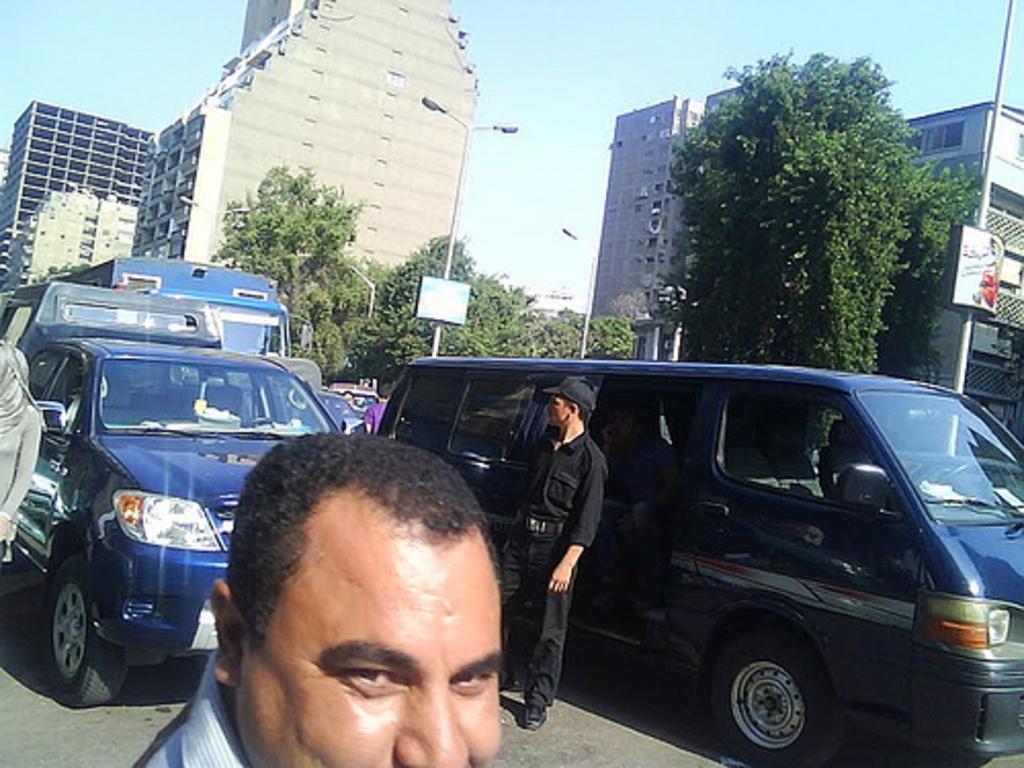Could you give a brief overview of what you see in this image? In this picture we can see there are vehicles and people on the road. Behind the vehicles, there are trees, street lights, buildings, a board and the sky. 